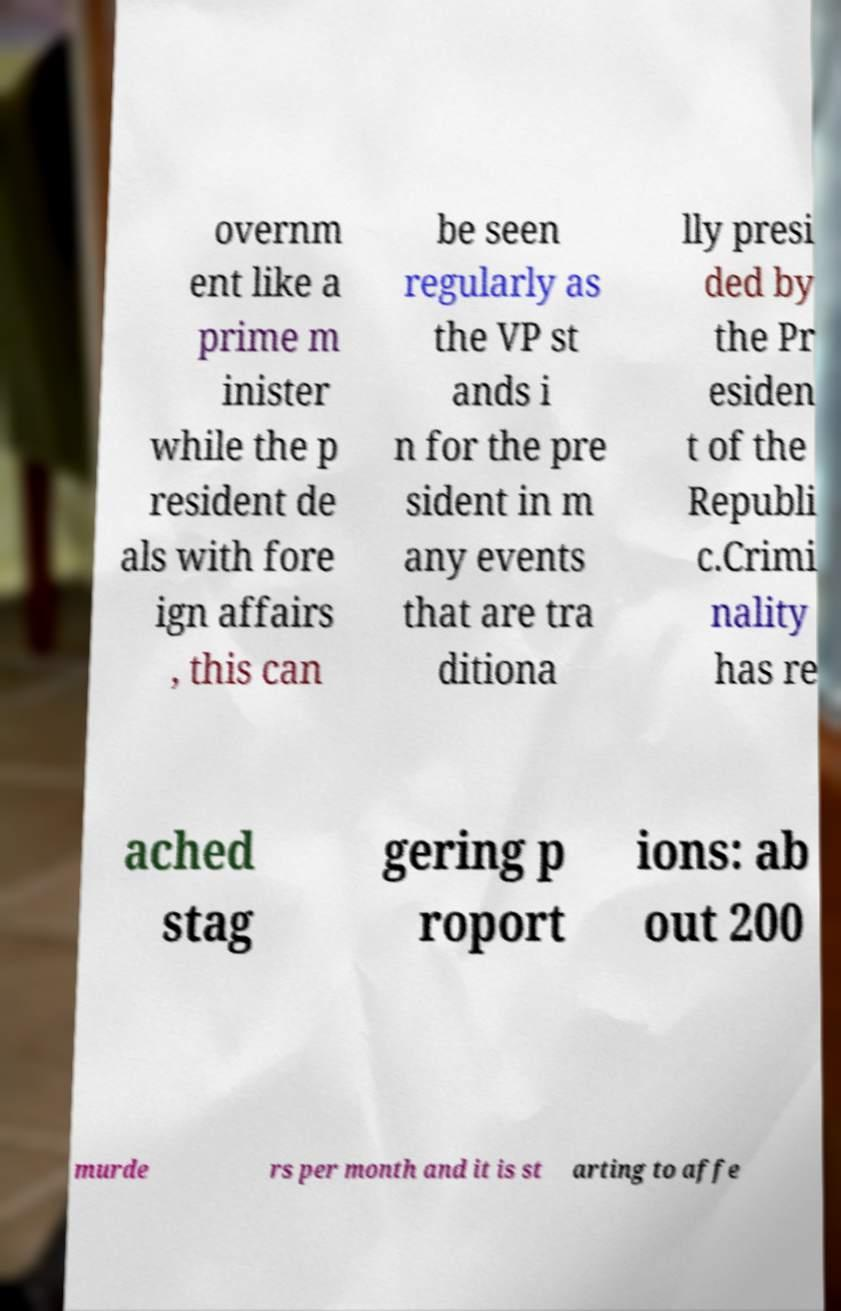Can you read and provide the text displayed in the image?This photo seems to have some interesting text. Can you extract and type it out for me? overnm ent like a prime m inister while the p resident de als with fore ign affairs , this can be seen regularly as the VP st ands i n for the pre sident in m any events that are tra ditiona lly presi ded by the Pr esiden t of the Republi c.Crimi nality has re ached stag gering p roport ions: ab out 200 murde rs per month and it is st arting to affe 